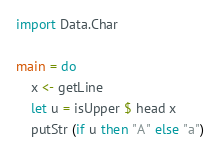Convert code to text. <code><loc_0><loc_0><loc_500><loc_500><_Haskell_>import Data.Char

main = do
    x <- getLine 
    let u = isUpper $ head x
    putStr (if u then "A" else "a")
</code> 